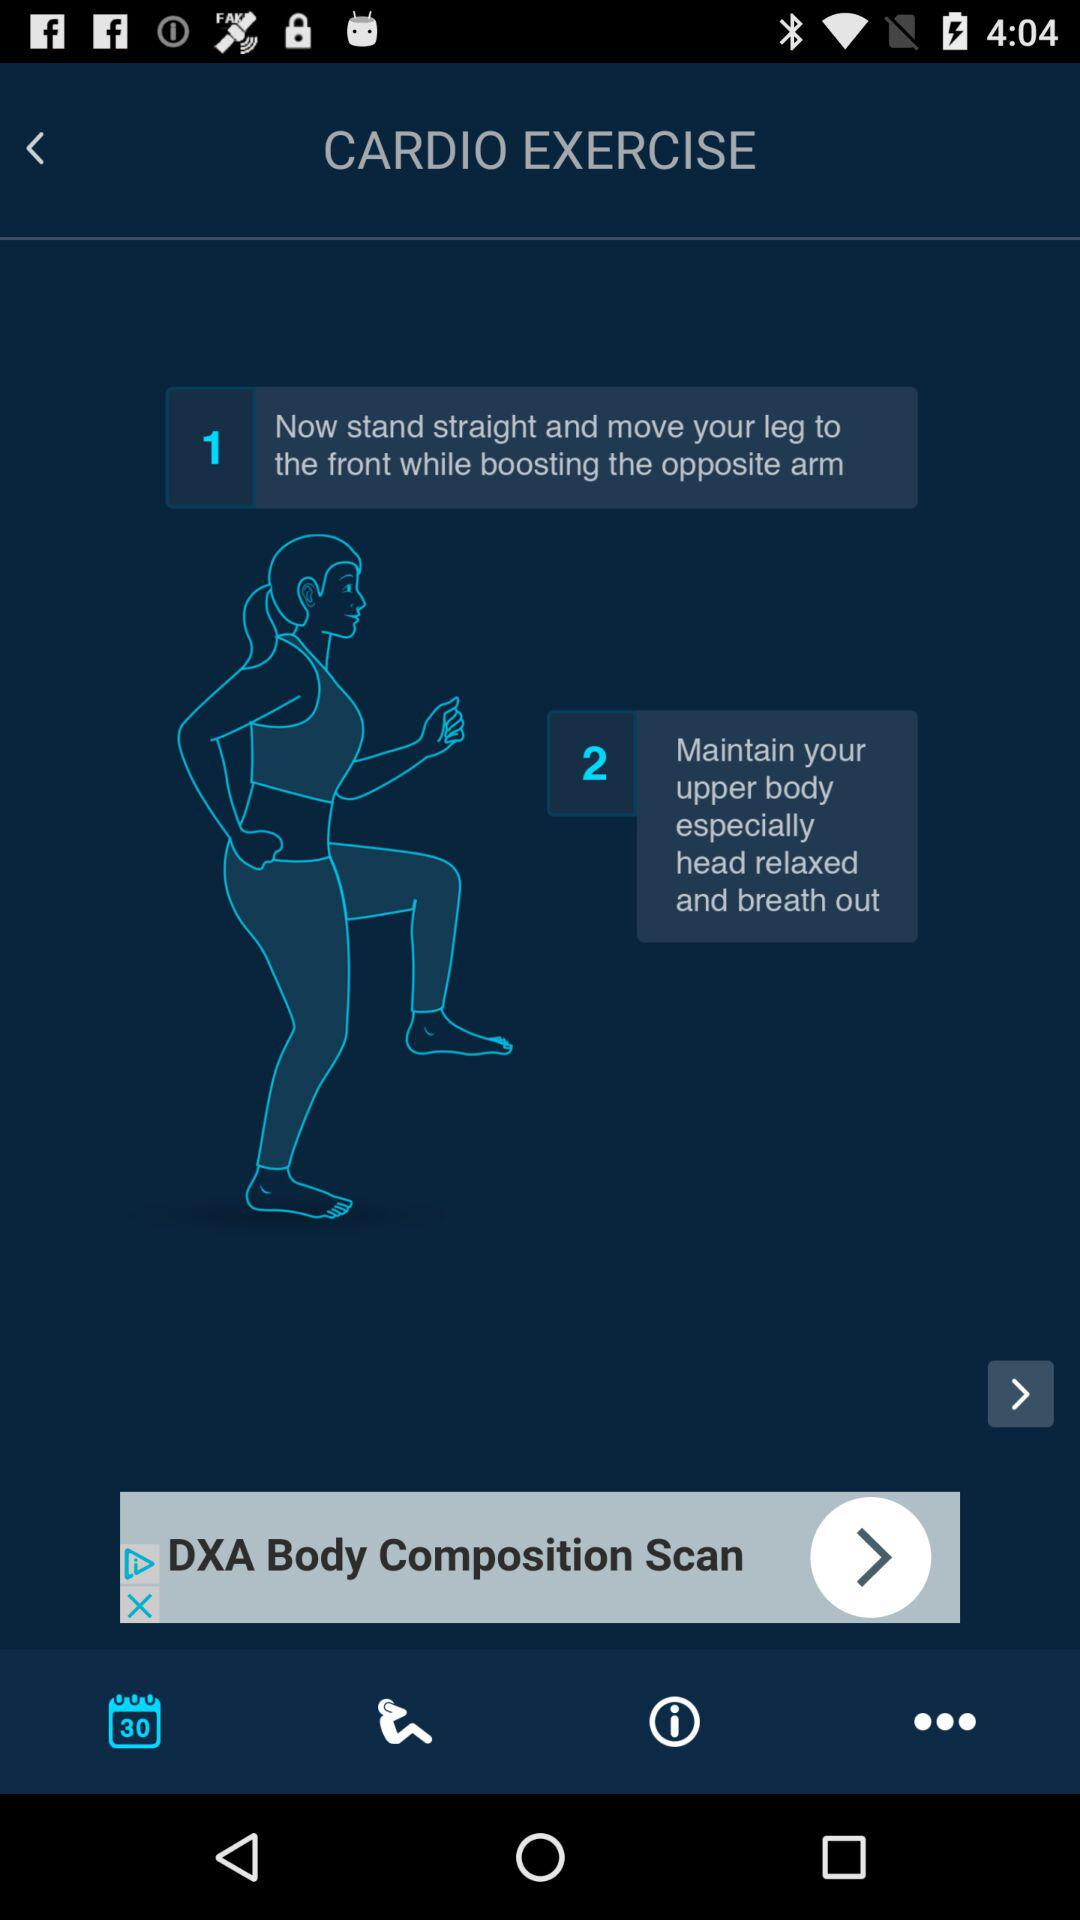How many more instructions are there for the first exercise than the second?
Answer the question using a single word or phrase. 1 